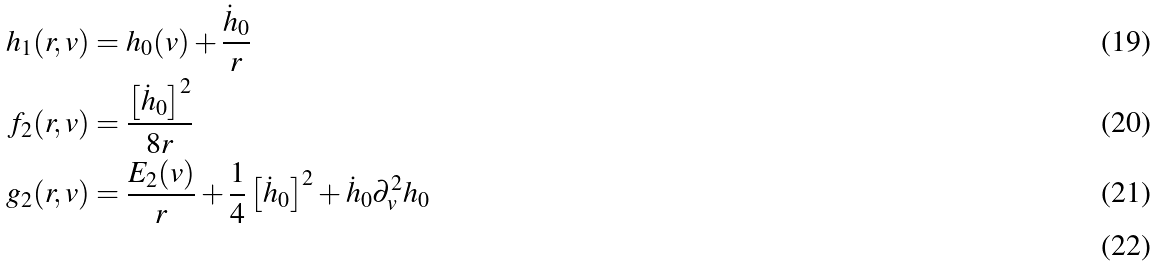<formula> <loc_0><loc_0><loc_500><loc_500>h _ { 1 } ( r , v ) & = h _ { 0 } ( v ) + \frac { { \dot { h } } _ { 0 } } { r } \\ f _ { 2 } ( r , v ) & = \frac { \left [ { \dot { h } } _ { 0 } \right ] ^ { 2 } } { 8 r } \\ g _ { 2 } ( r , v ) & = \frac { E _ { 2 } ( v ) } { r } + \frac { 1 } { 4 } \left [ { \dot { h } } _ { 0 } \right ] ^ { 2 } + { \dot { h } } _ { 0 } \partial _ { v } ^ { 2 } h _ { 0 } \\</formula> 